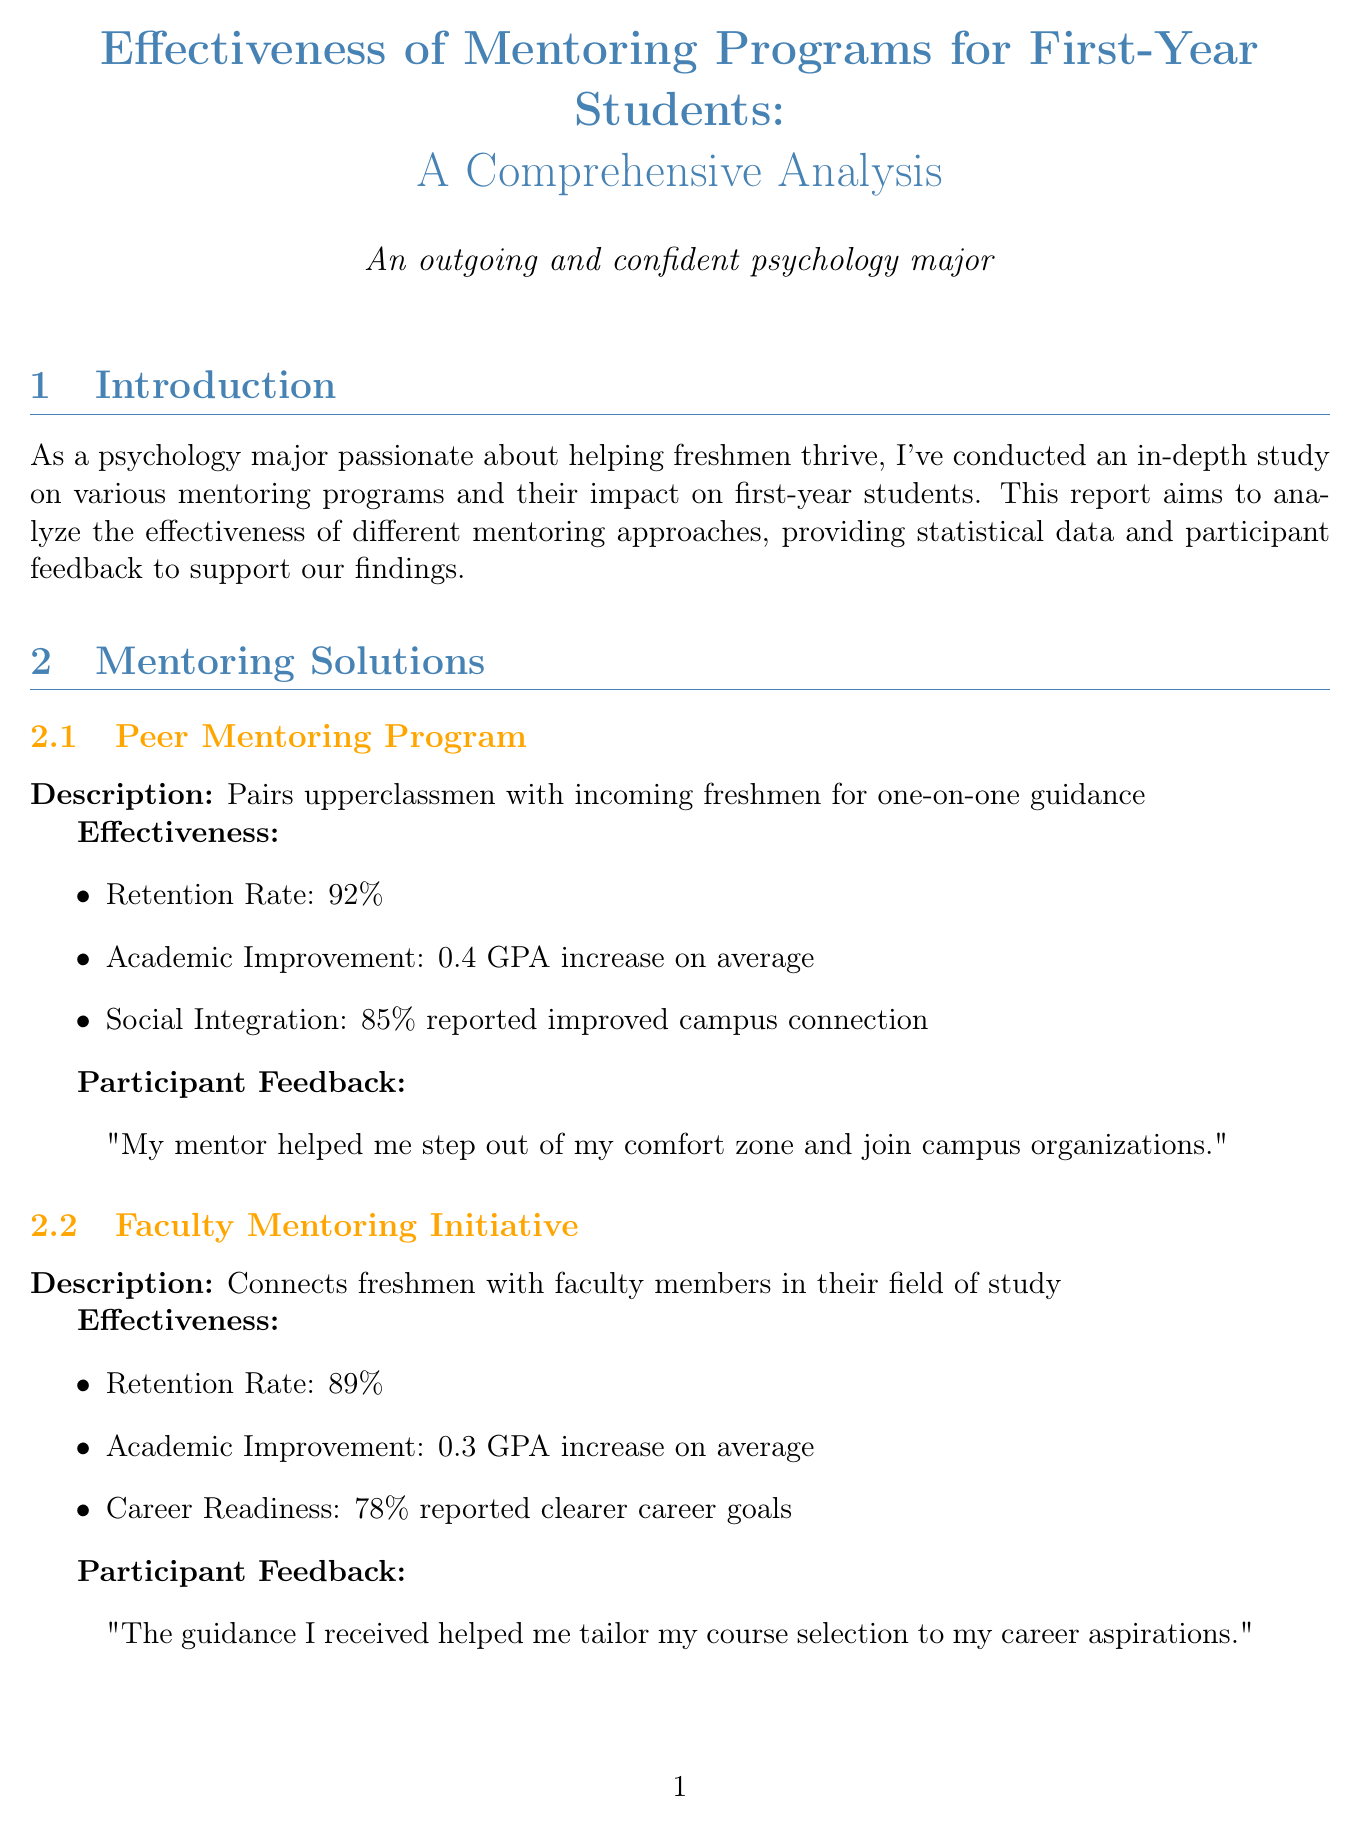what is the retention rate of the Peer Mentoring Program? The retention rate of the Peer Mentoring Program is specifically mentioned in the effectiveness section of the report.
Answer: 92% what percentage of mentored students reported increased belief in their ability to succeed? This information is found in the psychological benefits section of the report, detailing student experiences.
Answer: 82% what improvement in GPA is noted for participants in the Faculty Mentoring Initiative? The document provides specific statistics on academic improvement for this particular mentoring approach.
Answer: 0.3 GPA increase which mentoring program had the highest retention rate? The report outlines the retention rates of various mentoring programs, allowing us to compare them directly.
Answer: Triton Mentorship Program how many new connections did Group Mentoring Circles participants make on average? The effectiveness metrics for Group Mentoring Circles include social network growth, which specifies this data point.
Answer: Average of 7 new connections what is the overall retention improvement for mentored students compared to non-mentored students? A comparative statistic regarding retention improvement is provided in the statistical analysis section of the document.
Answer: 15% what percentage of freshmen engaged in at least one mentoring program? The report includes data on mentoring program participation in its statistical analysis section.
Answer: 72% what are two implementation strategies from the Triton Mentorship Program? The key findings section lists specific strategies used in the program to enhance mentoring effectiveness.
Answer: Mandatory mentor training sessions, Monthly check-ins with program coordinators what should psychology students do according to the conclusion of the report? The conclusion provides a call to action directed at psychology students regarding their involvement in mentoring initiatives.
Answer: Encourage freshmen to participate in these programs 